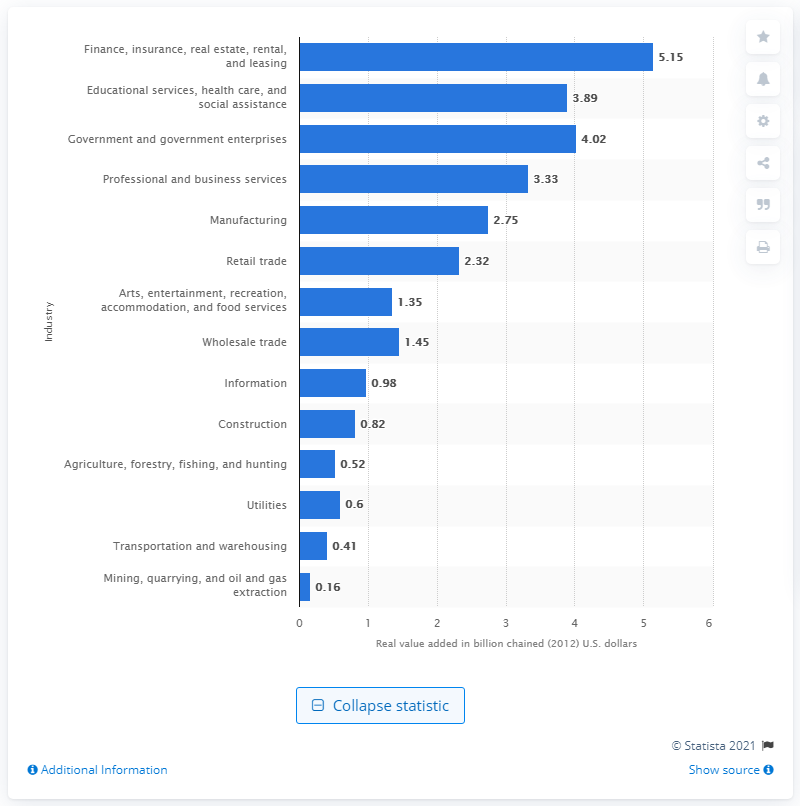Draw attention to some important aspects in this diagram. The finance, insurance, real estate, rental, and leasing industry contributed 5.15 billion dollars to the gross domestic product (GDP) of Vermont in 2012. 